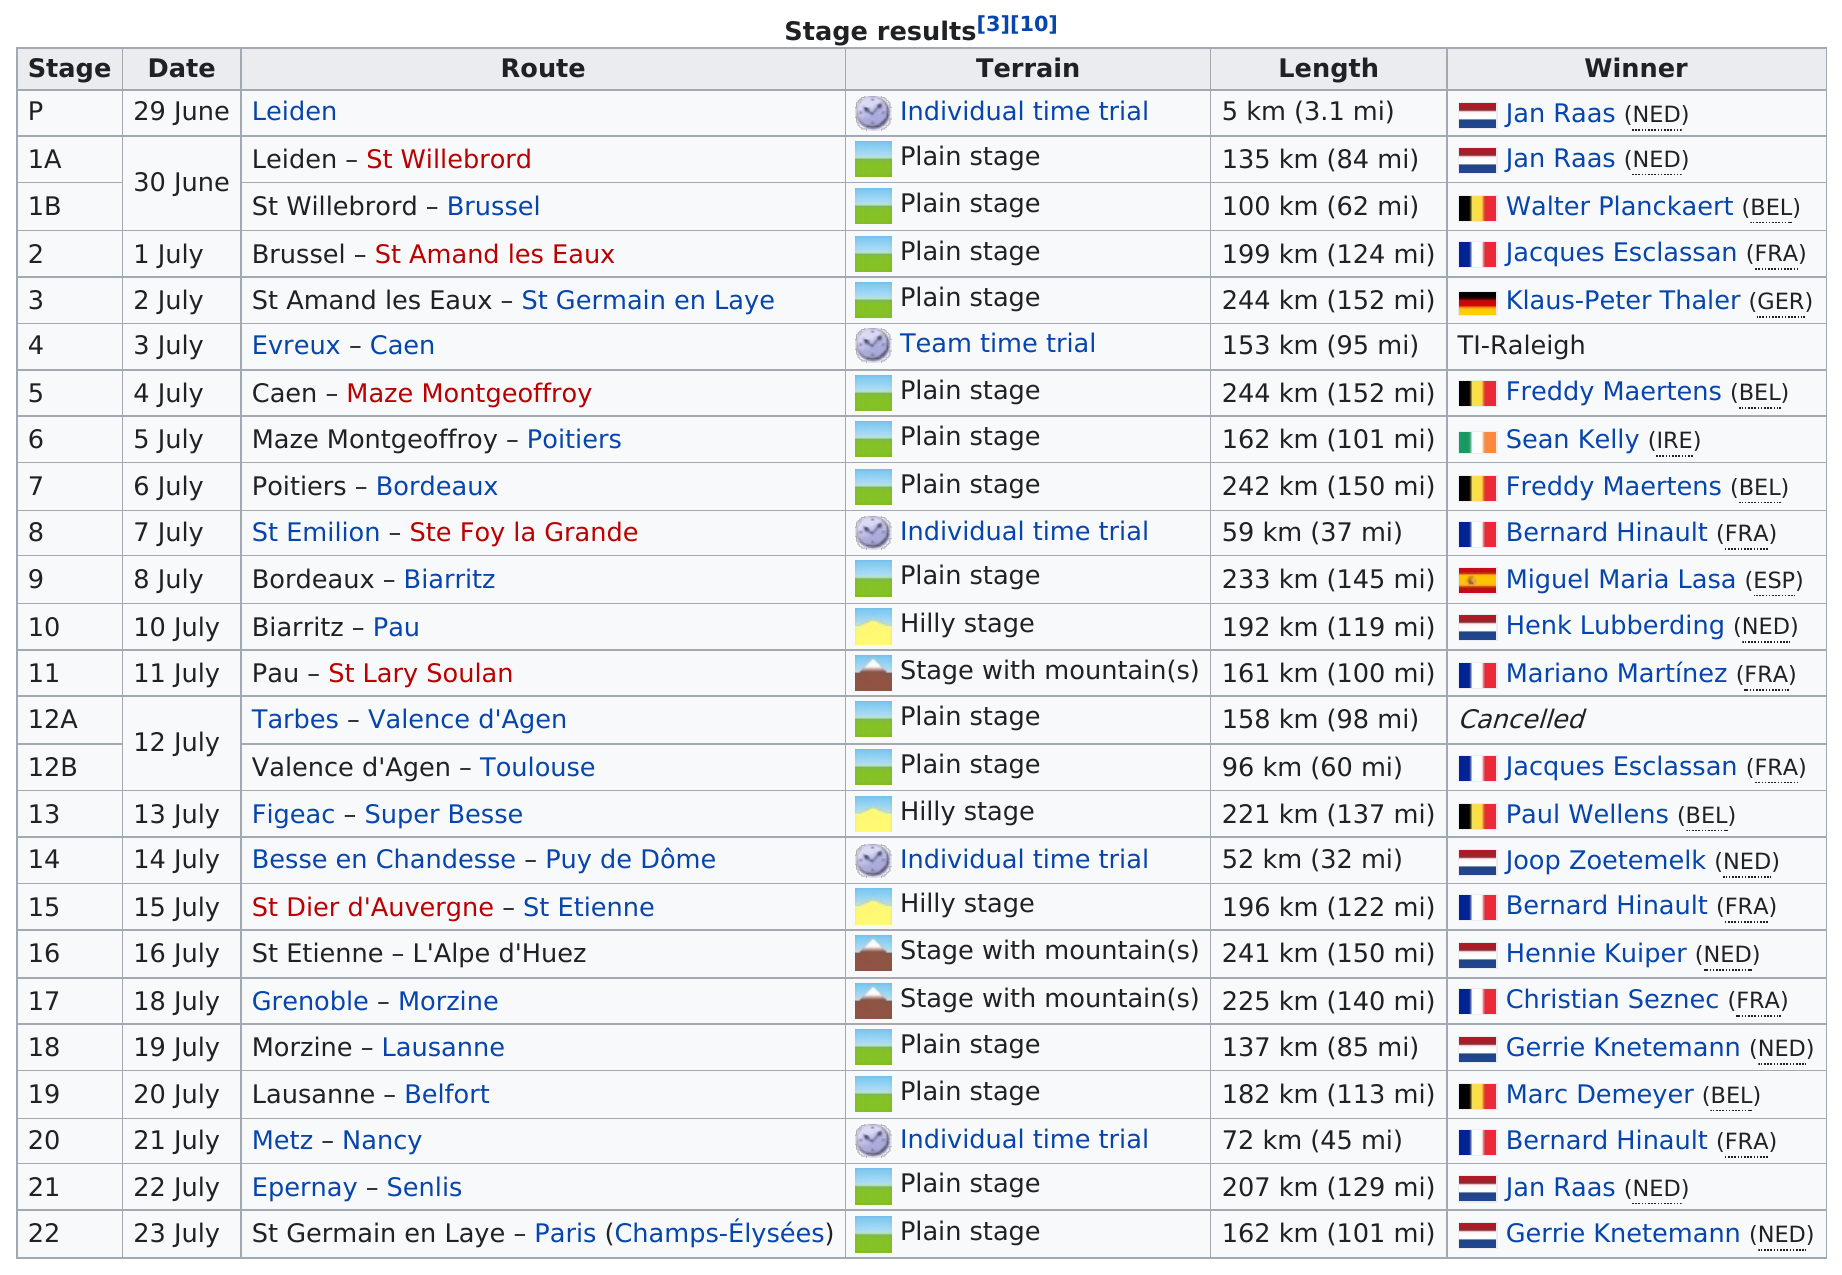Point out several critical features in this image. In the Tour de France, there are 3 stages that contain mountains. The first route on this chart is called "Leiden. Plain terrain is the most frequently mentioned type of terrain in the given list. The distance between Metz and Nancy is approximately 45 miles. Sean Kelly has the distinction of winning only one stage, which was at stage 6. 